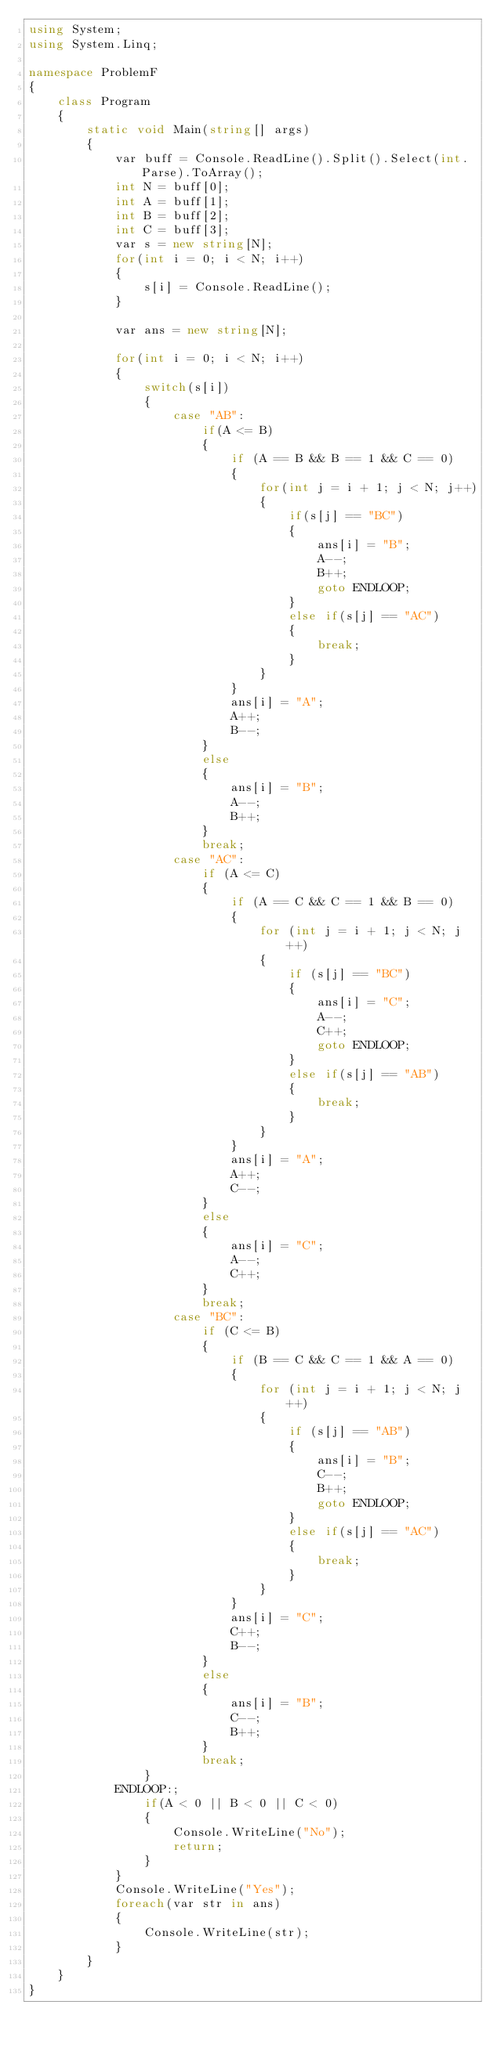Convert code to text. <code><loc_0><loc_0><loc_500><loc_500><_C#_>using System;
using System.Linq;

namespace ProblemF
{
    class Program
    {
        static void Main(string[] args)
        {
            var buff = Console.ReadLine().Split().Select(int.Parse).ToArray();
            int N = buff[0];
            int A = buff[1];
            int B = buff[2];
            int C = buff[3];
            var s = new string[N];
            for(int i = 0; i < N; i++)
            {
                s[i] = Console.ReadLine();
            }

            var ans = new string[N];

            for(int i = 0; i < N; i++)
            {
                switch(s[i])
                {
                    case "AB":
                        if(A <= B)
                        {
                            if (A == B && B == 1 && C == 0)
                            {
                                for(int j = i + 1; j < N; j++)
                                {
                                    if(s[j] == "BC")
                                    {
                                        ans[i] = "B";
                                        A--;
                                        B++;
                                        goto ENDLOOP;
                                    }
                                    else if(s[j] == "AC")
                                    {
                                        break;
                                    }
                                }
                            }
                            ans[i] = "A";
                            A++;
                            B--;
                        }
                        else
                        {
                            ans[i] = "B";
                            A--;
                            B++;
                        }
                        break;
                    case "AC":
                        if (A <= C)
                        {
                            if (A == C && C == 1 && B == 0)
                            {
                                for (int j = i + 1; j < N; j++)
                                {
                                    if (s[j] == "BC")
                                    {
                                        ans[i] = "C";
                                        A--;
                                        C++;
                                        goto ENDLOOP;
                                    }
                                    else if(s[j] == "AB")
                                    {
                                        break;
                                    }
                                }
                            }
                            ans[i] = "A";
                            A++;
                            C--;
                        }
                        else
                        {
                            ans[i] = "C";
                            A--;
                            C++;
                        }
                        break;
                    case "BC":
                        if (C <= B)
                        {
                            if (B == C && C == 1 && A == 0)
                            {
                                for (int j = i + 1; j < N; j++)
                                {
                                    if (s[j] == "AB")
                                    {
                                        ans[i] = "B";
                                        C--;
                                        B++;
                                        goto ENDLOOP;
                                    }
                                    else if(s[j] == "AC")
                                    {
                                        break;
                                    }
                                }
                            }
                            ans[i] = "C";
                            C++;
                            B--;
                        }
                        else
                        {
                            ans[i] = "B";
                            C--;
                            B++;
                        }
                        break;
                }
            ENDLOOP:;
                if(A < 0 || B < 0 || C < 0)
                {
                    Console.WriteLine("No");
                    return;
                }
            }
            Console.WriteLine("Yes");
            foreach(var str in ans)
            {
                Console.WriteLine(str);
            }
        }
    }
}
</code> 